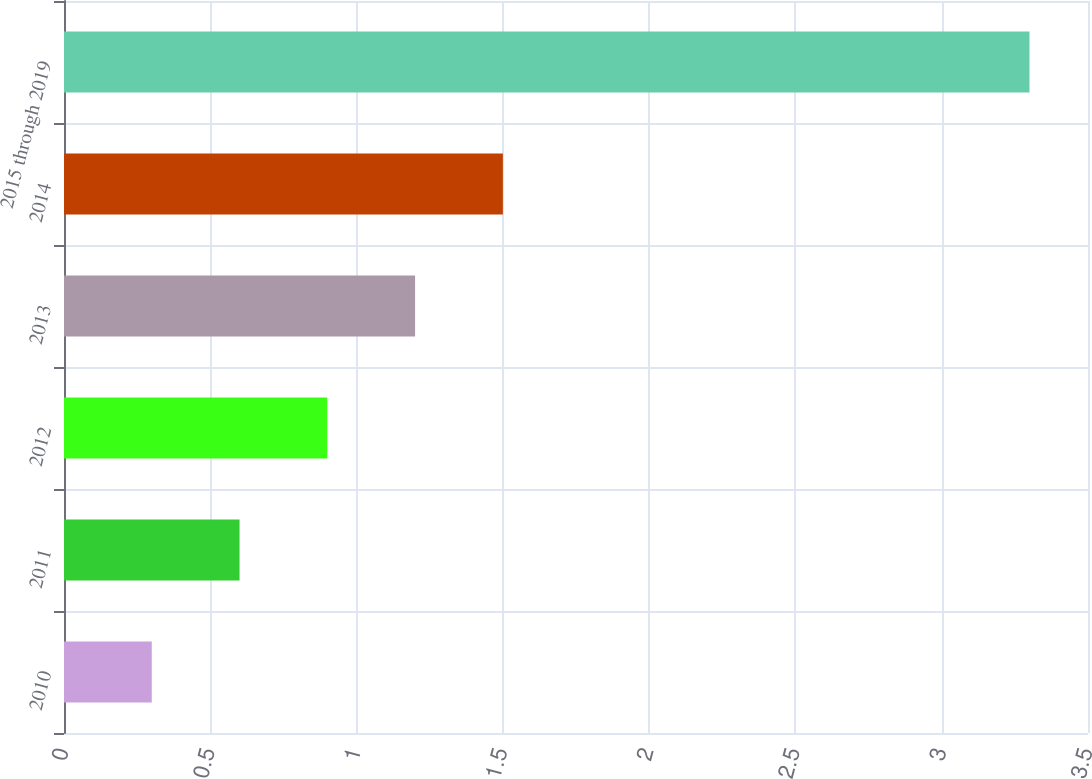<chart> <loc_0><loc_0><loc_500><loc_500><bar_chart><fcel>2010<fcel>2011<fcel>2012<fcel>2013<fcel>2014<fcel>2015 through 2019<nl><fcel>0.3<fcel>0.6<fcel>0.9<fcel>1.2<fcel>1.5<fcel>3.3<nl></chart> 